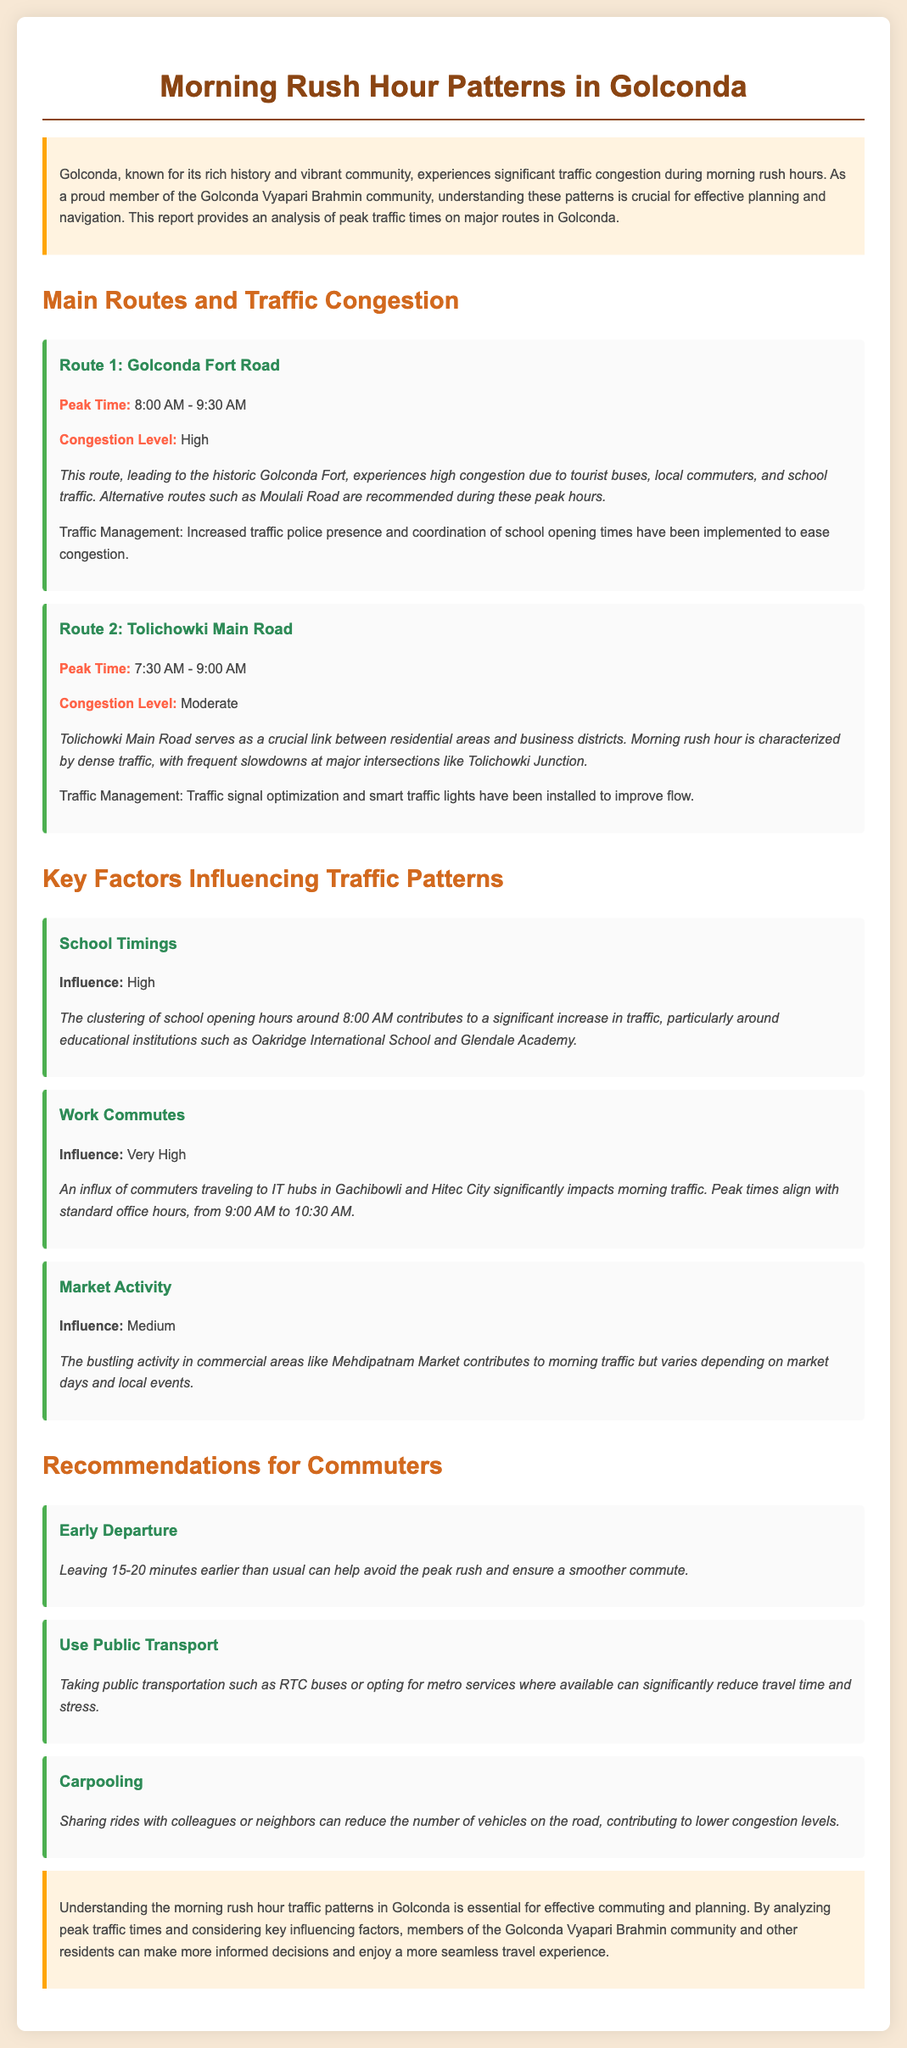What is the peak time for Golconda Fort Road? The peak time for Golconda Fort Road is mentioned in the report as 8:00 AM - 9:30 AM.
Answer: 8:00 AM - 9:30 AM What is the congestion level on Tolichowki Main Road? The congestion level for Tolichowki Main Road is stated as Moderate in the document.
Answer: Moderate What key factor has a very high influence on traffic? The document specifies that Work Commutes have a Very High influence on traffic patterns.
Answer: Work Commutes When should commuters consider leaving to avoid peak rush? The report recommends commuters to leave 15-20 minutes earlier than usual.
Answer: 15-20 minutes earlier Which alternative route is recommended during high congestion on Golconda Fort Road? The report suggests Moulali Road as an alternative route during high congestion times on Golconda Fort Road.
Answer: Moulali Road What is the peak time for Tolichowki Main Road? According to the report, the peak time for Tolichowki Main Road is 7:30 AM - 9:00 AM.
Answer: 7:30 AM - 9:00 AM What influence level is associated with school timings? The influence level for School Timings is noted as High in the document.
Answer: High What is one method suggested for reducing congestion? One method suggested for reducing congestion is Carpooling, as stated in the report.
Answer: Carpooling What commercial area contributes to morning traffic according to the report? The document mentions Mehdipatnam Market as contributing to morning traffic.
Answer: Mehdipatnam Market 